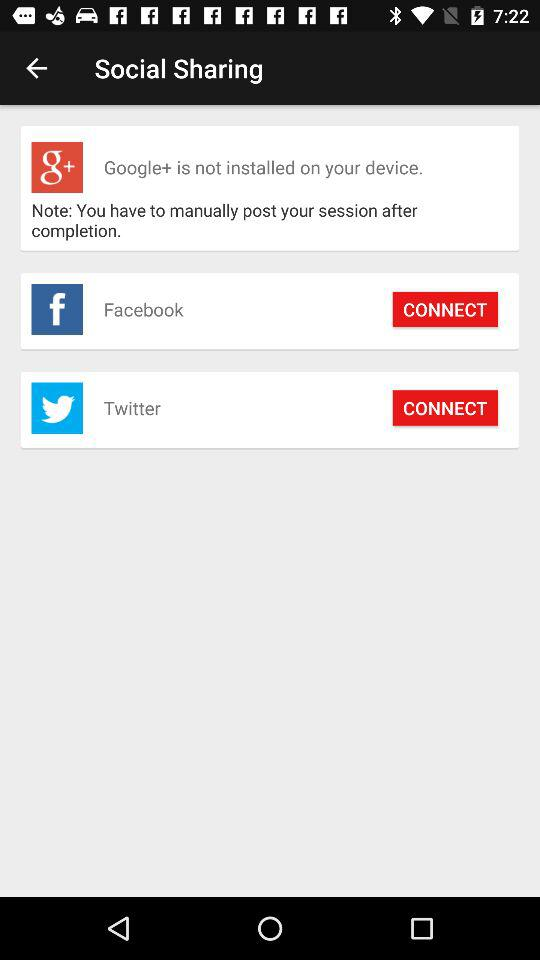How many social media platforms can I share my session to?
Answer the question using a single word or phrase. 3 